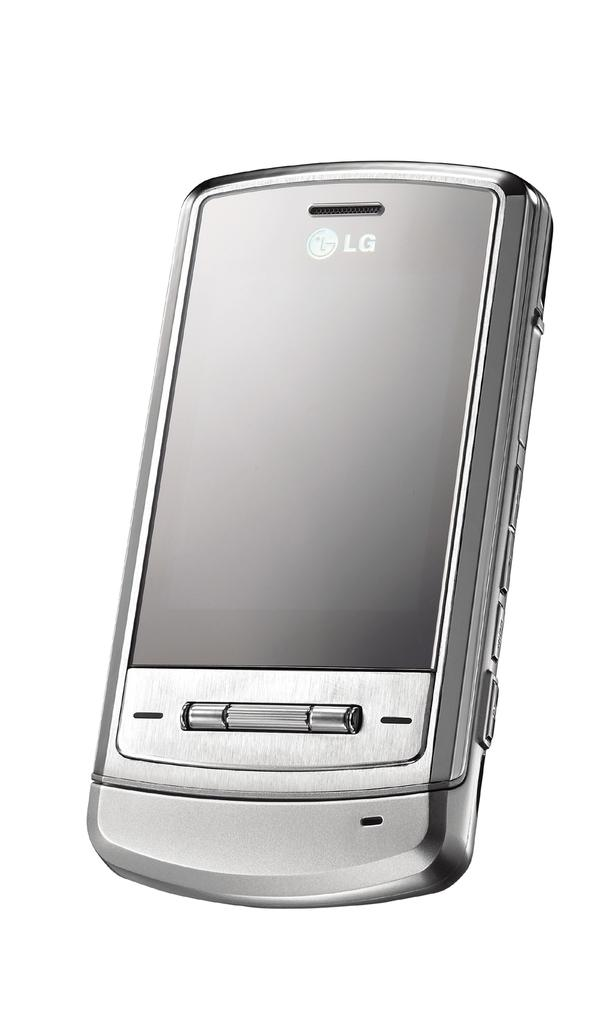<image>
Give a short and clear explanation of the subsequent image. A silver cell phone, branded LG, is displayed on a white background. 